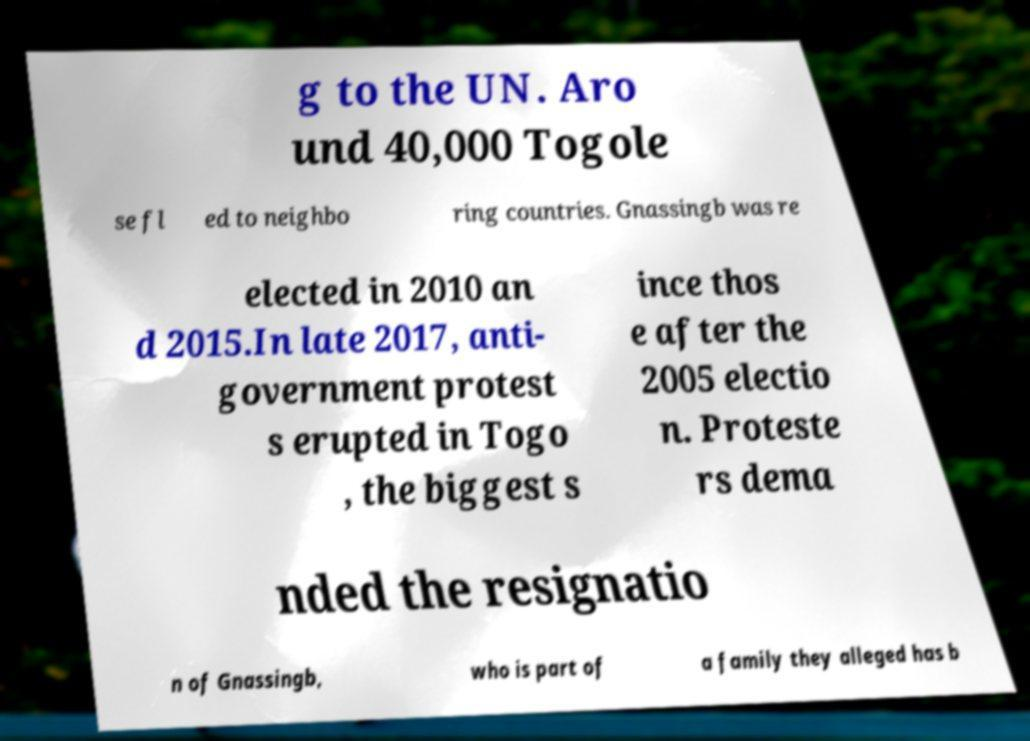Can you read and provide the text displayed in the image?This photo seems to have some interesting text. Can you extract and type it out for me? g to the UN. Aro und 40,000 Togole se fl ed to neighbo ring countries. Gnassingb was re elected in 2010 an d 2015.In late 2017, anti- government protest s erupted in Togo , the biggest s ince thos e after the 2005 electio n. Proteste rs dema nded the resignatio n of Gnassingb, who is part of a family they alleged has b 